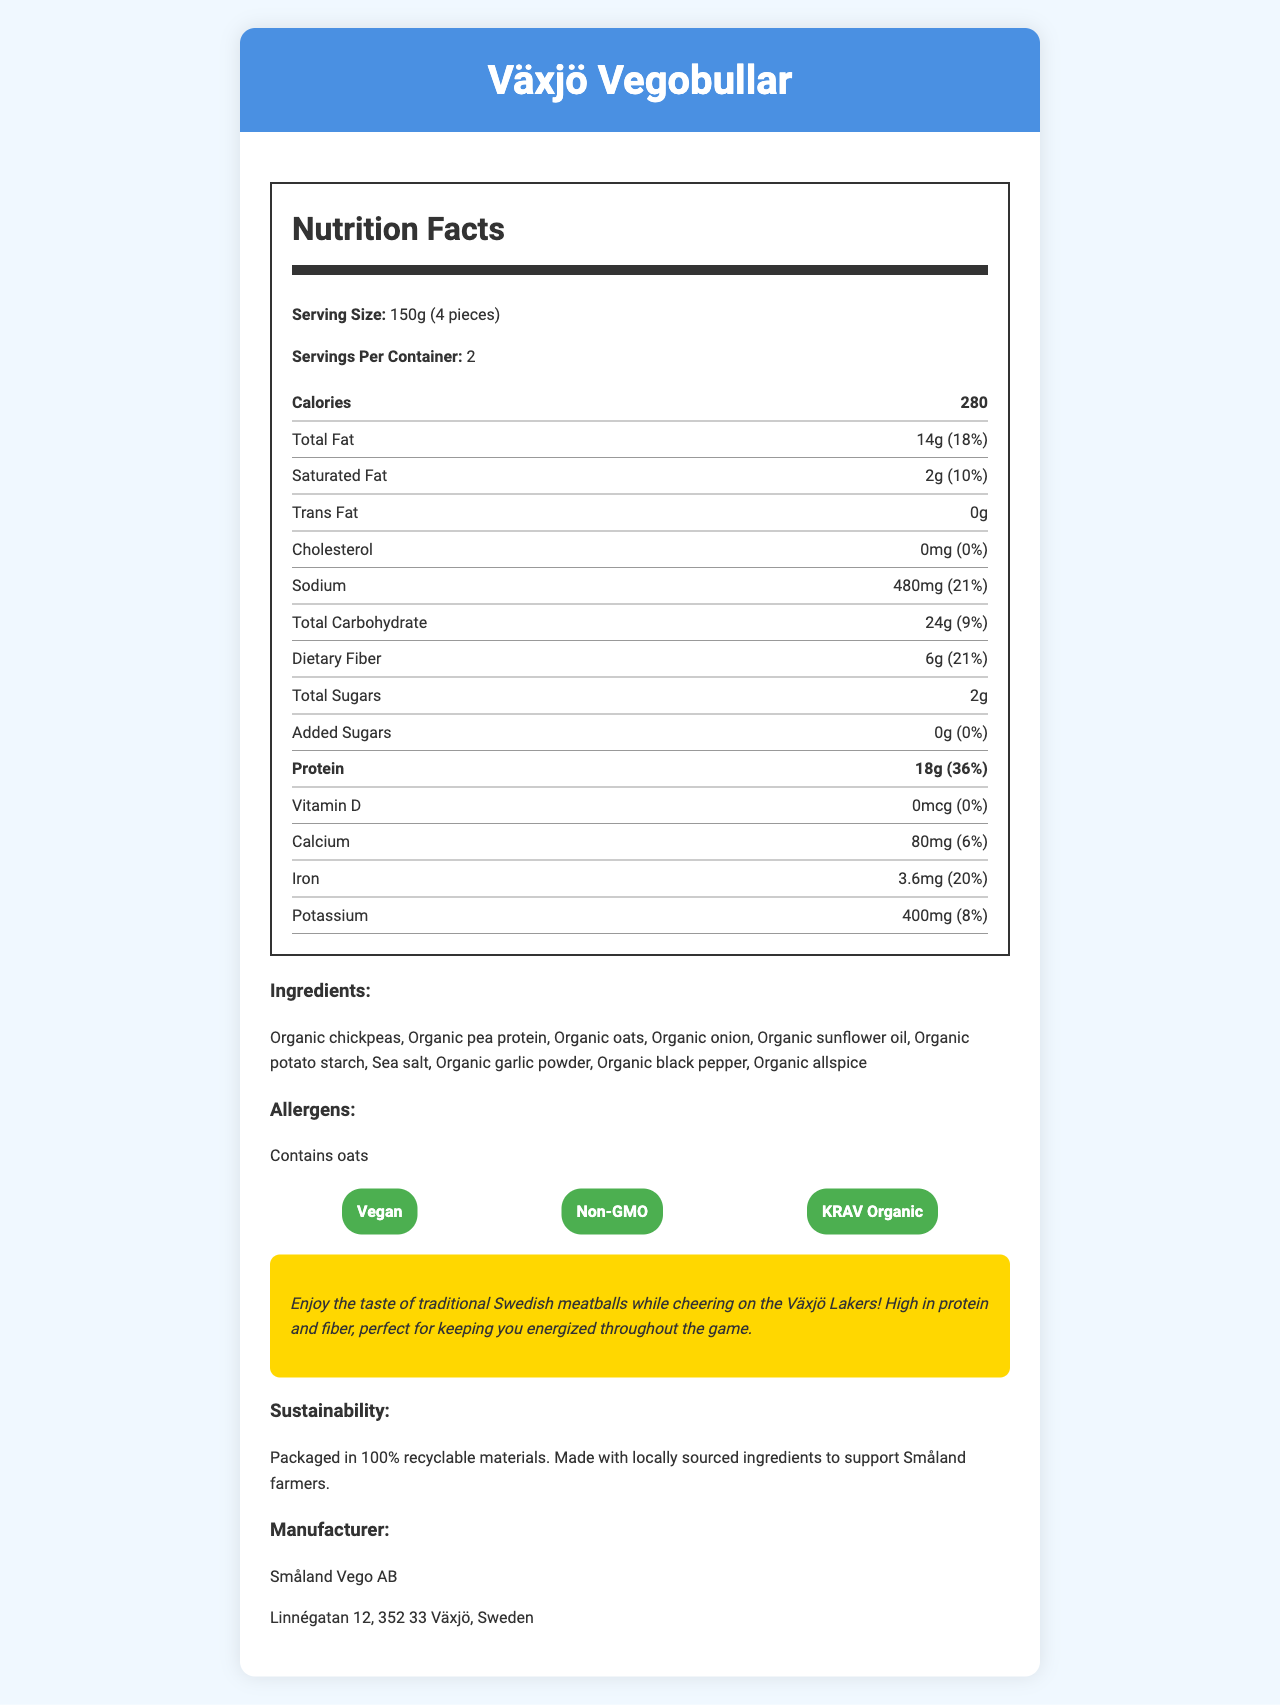what is the serving size for Växjö Vegobullar? The serving size is listed directly in the document as "150g (4 pieces)".
Answer: 150g (4 pieces) how much protein is in one serving of Växjö Vegobullar? The amount of protein per serving is specified in the nutrition facts section as 18g.
Answer: 18g what is the percentage daily value of protein per serving? The protein's daily value percentage per serving is given as 36%.
Answer: 36% what are the main ingredients in Växjö Vegobullar? The ingredients are listed directly in the document.
Answer: Organic chickpeas, Organic pea protein, Organic oats, Organic onion, Organic sunflower oil, Organic potato starch, Sea salt, Organic garlic powder, Organic black pepper, Organic allspice which certification does Växjö Vegobullar NOT have? A. Vegan B. Gluten-free C. Non-GMO D. KRAV Organic The certifications listed are Vegan, Non-GMO, and KRAV Organic. Gluten-free is not included.
Answer: B. Gluten-free how much sodium does one serving contain? The sodium content per serving is given as 480mg.
Answer: 480mg is there any added sugar in Växjö Vegobullar? The added sugar amount is listed as 0g and the daily value percentage as 0%.
Answer: No who is the manufacturer of Växjö Vegobullar? The manufacturer information listed is "Småland Vego AB".
Answer: Småland Vego AB does Växjö Vegobullar contain any cholesterol? The cholesterol amount is listed as 0mg and the daily value percentage as 0%.
Answer: No what is one of the allergens in Växjö Vegobullar? A. Milk B. Gluten C. Oats D. Nuts The allergen listed in the document is oats.
Answer: C. Oats describe the promotional message for Växjö Vegobullar. The promotional text in the document emphasizes the enjoyable taste of Swedish meatballs, high in protein and fiber, which helps keep you energized during the game.
Answer: Enjoy the taste of traditional Swedish meatballs while cheering on the Växjö Lakers! High in protein and fiber, perfect for keeping you energized throughout the game. how many servings are in a container of Växjö Vegobullar? The servings per container is specified as 2.
Answer: 2 what is the main idea of the document? The document focuses on detailing the nutritional aspects, ingredients, certifications, and a promotional text aimed at Växjö Lakers fans.
Answer: The document provides nutritional information, ingredients, allergen details, certifications, and a promotional message for Växjö Vegobullar, a vegetarian alternative to Swedish meatballs, emphasizing its protein content which is served at Växjö Lakers ice hockey games. what is the sustainability information provided for Växjö Vegobullar? The sustainability information states that the product is packaged in 100% recyclable materials and made with locally sourced ingredients.
Answer: Packaged in 100% recyclable materials. Made with locally sourced ingredients to support Småland farmers. what percentage daily value of dietary fiber is in a serving of Växjö Vegobullar? The daily value percentage for dietary fiber per serving is listed as 21%.
Answer: 21% is there any vitamin D in Växjö Vegobullar? The amount of vitamin D is listed as 0mcg and the daily value percentage as 0%.
Answer: No how many calories are in one serving of Växjö Vegobullar? The calorie content per serving is given as 280.
Answer: 280 calories what is the address of the manufacturer of Växjö Vegobullar? The manufacturer information includes the address "Linnégatan 12, 352 33 Växjö, Sweden".
Answer: Linnégatan 12, 352 33 Växjö, Sweden does Växjö Vegobullar use ingredients sourced from Småland farmers? The sustainability section mentions that the ingredients are locally sourced to support Småland farmers.
Answer: Yes what is the serving size for both Växjö Vegobullar and Växjö Köttbullar? The document only provides the serving size for Växjö Vegobullar and does not mention Växjö Köttbullar.
Answer: Not enough information 